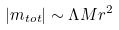<formula> <loc_0><loc_0><loc_500><loc_500>| m _ { t o t } | \sim \Lambda M r ^ { 2 }</formula> 